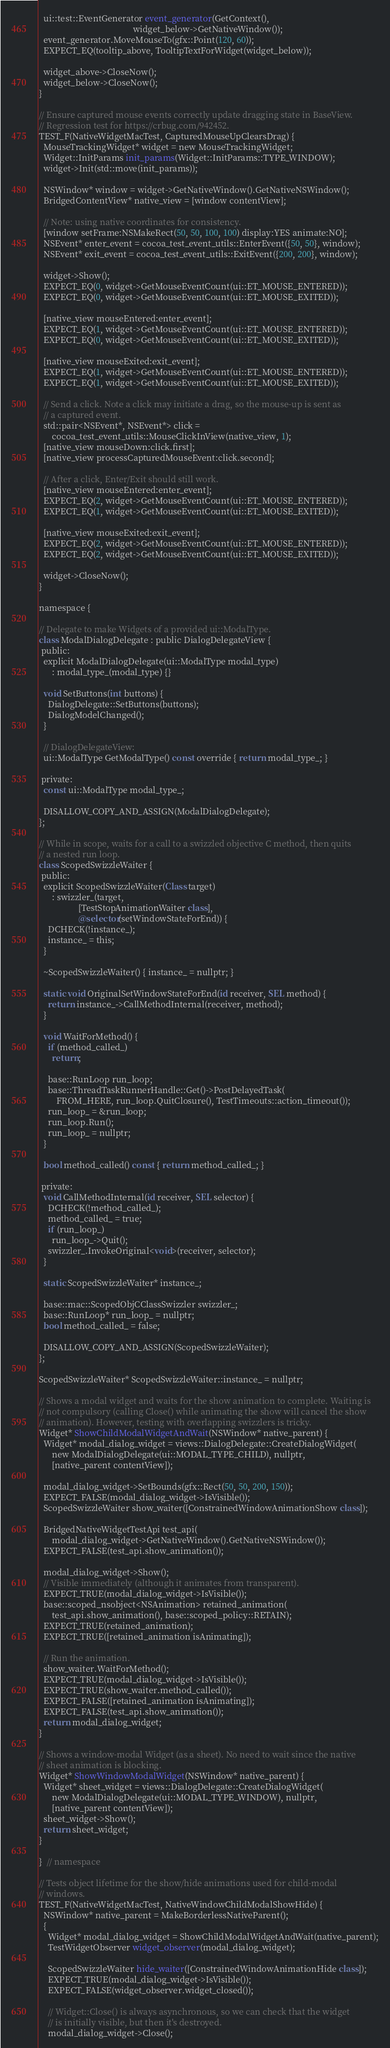<code> <loc_0><loc_0><loc_500><loc_500><_ObjectiveC_>  ui::test::EventGenerator event_generator(GetContext(),
                                           widget_below->GetNativeWindow());
  event_generator.MoveMouseTo(gfx::Point(120, 60));
  EXPECT_EQ(tooltip_above, TooltipTextForWidget(widget_below));

  widget_above->CloseNow();
  widget_below->CloseNow();
}

// Ensure captured mouse events correctly update dragging state in BaseView.
// Regression test for https://crbug.com/942452.
TEST_F(NativeWidgetMacTest, CapturedMouseUpClearsDrag) {
  MouseTrackingWidget* widget = new MouseTrackingWidget;
  Widget::InitParams init_params(Widget::InitParams::TYPE_WINDOW);
  widget->Init(std::move(init_params));

  NSWindow* window = widget->GetNativeWindow().GetNativeNSWindow();
  BridgedContentView* native_view = [window contentView];

  // Note: using native coordinates for consistency.
  [window setFrame:NSMakeRect(50, 50, 100, 100) display:YES animate:NO];
  NSEvent* enter_event = cocoa_test_event_utils::EnterEvent({50, 50}, window);
  NSEvent* exit_event = cocoa_test_event_utils::ExitEvent({200, 200}, window);

  widget->Show();
  EXPECT_EQ(0, widget->GetMouseEventCount(ui::ET_MOUSE_ENTERED));
  EXPECT_EQ(0, widget->GetMouseEventCount(ui::ET_MOUSE_EXITED));

  [native_view mouseEntered:enter_event];
  EXPECT_EQ(1, widget->GetMouseEventCount(ui::ET_MOUSE_ENTERED));
  EXPECT_EQ(0, widget->GetMouseEventCount(ui::ET_MOUSE_EXITED));

  [native_view mouseExited:exit_event];
  EXPECT_EQ(1, widget->GetMouseEventCount(ui::ET_MOUSE_ENTERED));
  EXPECT_EQ(1, widget->GetMouseEventCount(ui::ET_MOUSE_EXITED));

  // Send a click. Note a click may initiate a drag, so the mouse-up is sent as
  // a captured event.
  std::pair<NSEvent*, NSEvent*> click =
      cocoa_test_event_utils::MouseClickInView(native_view, 1);
  [native_view mouseDown:click.first];
  [native_view processCapturedMouseEvent:click.second];

  // After a click, Enter/Exit should still work.
  [native_view mouseEntered:enter_event];
  EXPECT_EQ(2, widget->GetMouseEventCount(ui::ET_MOUSE_ENTERED));
  EXPECT_EQ(1, widget->GetMouseEventCount(ui::ET_MOUSE_EXITED));

  [native_view mouseExited:exit_event];
  EXPECT_EQ(2, widget->GetMouseEventCount(ui::ET_MOUSE_ENTERED));
  EXPECT_EQ(2, widget->GetMouseEventCount(ui::ET_MOUSE_EXITED));

  widget->CloseNow();
}

namespace {

// Delegate to make Widgets of a provided ui::ModalType.
class ModalDialogDelegate : public DialogDelegateView {
 public:
  explicit ModalDialogDelegate(ui::ModalType modal_type)
      : modal_type_(modal_type) {}

  void SetButtons(int buttons) {
    DialogDelegate::SetButtons(buttons);
    DialogModelChanged();
  }

  // DialogDelegateView:
  ui::ModalType GetModalType() const override { return modal_type_; }

 private:
  const ui::ModalType modal_type_;

  DISALLOW_COPY_AND_ASSIGN(ModalDialogDelegate);
};

// While in scope, waits for a call to a swizzled objective C method, then quits
// a nested run loop.
class ScopedSwizzleWaiter {
 public:
  explicit ScopedSwizzleWaiter(Class target)
      : swizzler_(target,
                  [TestStopAnimationWaiter class],
                  @selector(setWindowStateForEnd)) {
    DCHECK(!instance_);
    instance_ = this;
  }

  ~ScopedSwizzleWaiter() { instance_ = nullptr; }

  static void OriginalSetWindowStateForEnd(id receiver, SEL method) {
    return instance_->CallMethodInternal(receiver, method);
  }

  void WaitForMethod() {
    if (method_called_)
      return;

    base::RunLoop run_loop;
    base::ThreadTaskRunnerHandle::Get()->PostDelayedTask(
        FROM_HERE, run_loop.QuitClosure(), TestTimeouts::action_timeout());
    run_loop_ = &run_loop;
    run_loop.Run();
    run_loop_ = nullptr;
  }

  bool method_called() const { return method_called_; }

 private:
  void CallMethodInternal(id receiver, SEL selector) {
    DCHECK(!method_called_);
    method_called_ = true;
    if (run_loop_)
      run_loop_->Quit();
    swizzler_.InvokeOriginal<void>(receiver, selector);
  }

  static ScopedSwizzleWaiter* instance_;

  base::mac::ScopedObjCClassSwizzler swizzler_;
  base::RunLoop* run_loop_ = nullptr;
  bool method_called_ = false;

  DISALLOW_COPY_AND_ASSIGN(ScopedSwizzleWaiter);
};

ScopedSwizzleWaiter* ScopedSwizzleWaiter::instance_ = nullptr;

// Shows a modal widget and waits for the show animation to complete. Waiting is
// not compulsory (calling Close() while animating the show will cancel the show
// animation). However, testing with overlapping swizzlers is tricky.
Widget* ShowChildModalWidgetAndWait(NSWindow* native_parent) {
  Widget* modal_dialog_widget = views::DialogDelegate::CreateDialogWidget(
      new ModalDialogDelegate(ui::MODAL_TYPE_CHILD), nullptr,
      [native_parent contentView]);

  modal_dialog_widget->SetBounds(gfx::Rect(50, 50, 200, 150));
  EXPECT_FALSE(modal_dialog_widget->IsVisible());
  ScopedSwizzleWaiter show_waiter([ConstrainedWindowAnimationShow class]);

  BridgedNativeWidgetTestApi test_api(
      modal_dialog_widget->GetNativeWindow().GetNativeNSWindow());
  EXPECT_FALSE(test_api.show_animation());

  modal_dialog_widget->Show();
  // Visible immediately (although it animates from transparent).
  EXPECT_TRUE(modal_dialog_widget->IsVisible());
  base::scoped_nsobject<NSAnimation> retained_animation(
      test_api.show_animation(), base::scoped_policy::RETAIN);
  EXPECT_TRUE(retained_animation);
  EXPECT_TRUE([retained_animation isAnimating]);

  // Run the animation.
  show_waiter.WaitForMethod();
  EXPECT_TRUE(modal_dialog_widget->IsVisible());
  EXPECT_TRUE(show_waiter.method_called());
  EXPECT_FALSE([retained_animation isAnimating]);
  EXPECT_FALSE(test_api.show_animation());
  return modal_dialog_widget;
}

// Shows a window-modal Widget (as a sheet). No need to wait since the native
// sheet animation is blocking.
Widget* ShowWindowModalWidget(NSWindow* native_parent) {
  Widget* sheet_widget = views::DialogDelegate::CreateDialogWidget(
      new ModalDialogDelegate(ui::MODAL_TYPE_WINDOW), nullptr,
      [native_parent contentView]);
  sheet_widget->Show();
  return sheet_widget;
}

}  // namespace

// Tests object lifetime for the show/hide animations used for child-modal
// windows.
TEST_F(NativeWidgetMacTest, NativeWindowChildModalShowHide) {
  NSWindow* native_parent = MakeBorderlessNativeParent();
  {
    Widget* modal_dialog_widget = ShowChildModalWidgetAndWait(native_parent);
    TestWidgetObserver widget_observer(modal_dialog_widget);

    ScopedSwizzleWaiter hide_waiter([ConstrainedWindowAnimationHide class]);
    EXPECT_TRUE(modal_dialog_widget->IsVisible());
    EXPECT_FALSE(widget_observer.widget_closed());

    // Widget::Close() is always asynchronous, so we can check that the widget
    // is initially visible, but then it's destroyed.
    modal_dialog_widget->Close();</code> 